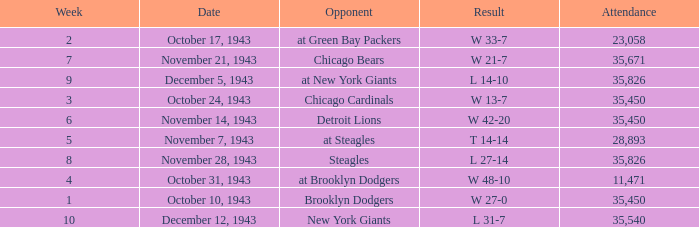What is the lowest week that has an attendance greater than 23,058, with october 24, 1943 as the date? 3.0. 